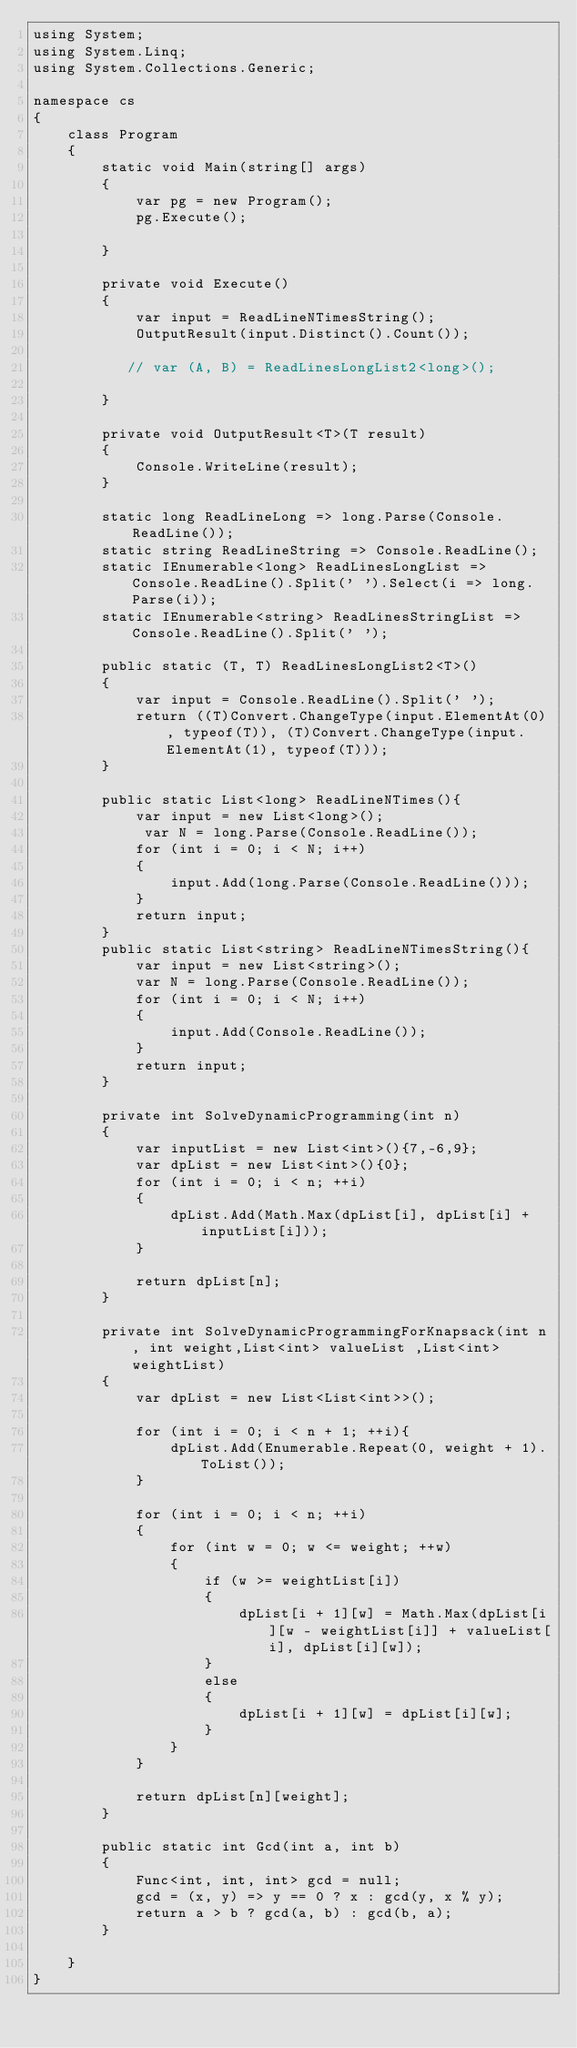<code> <loc_0><loc_0><loc_500><loc_500><_C#_>using System;
using System.Linq;
using System.Collections.Generic;

namespace cs
{
    class Program
    {
        static void Main(string[] args)
        {
            var pg = new Program();
            pg.Execute();

        }

        private void Execute()
        {
            var input = ReadLineNTimesString();
            OutputResult(input.Distinct().Count());

           // var (A, B) = ReadLinesLongList2<long>();

        }

        private void OutputResult<T>(T result)
        {
            Console.WriteLine(result);
        }

        static long ReadLineLong => long.Parse(Console.ReadLine());
        static string ReadLineString => Console.ReadLine();
        static IEnumerable<long> ReadLinesLongList => Console.ReadLine().Split(' ').Select(i => long.Parse(i));
        static IEnumerable<string> ReadLinesStringList => Console.ReadLine().Split(' ');

        public static (T, T) ReadLinesLongList2<T>()
        {
            var input = Console.ReadLine().Split(' ');
            return ((T)Convert.ChangeType(input.ElementAt(0), typeof(T)), (T)Convert.ChangeType(input.ElementAt(1), typeof(T)));
        }

        public static List<long> ReadLineNTimes(){
            var input = new List<long>();
             var N = long.Parse(Console.ReadLine());
            for (int i = 0; i < N; i++)
            {
                input.Add(long.Parse(Console.ReadLine()));
            }
            return input;
        }
        public static List<string> ReadLineNTimesString(){
            var input = new List<string>();
            var N = long.Parse(Console.ReadLine());
            for (int i = 0; i < N; i++)
            {
                input.Add(Console.ReadLine());
            }
            return input;
        }

        private int SolveDynamicProgramming(int n)
        {
            var inputList = new List<int>(){7,-6,9};
            var dpList = new List<int>(){0};
            for (int i = 0; i < n; ++i)
            {
                dpList.Add(Math.Max(dpList[i], dpList[i] + inputList[i]));
            }

            return dpList[n];
        }

        private int SolveDynamicProgrammingForKnapsack(int n, int weight,List<int> valueList ,List<int> weightList)
        {
            var dpList = new List<List<int>>();
            
            for (int i = 0; i < n + 1; ++i){
                dpList.Add(Enumerable.Repeat(0, weight + 1).ToList());
            }

            for (int i = 0; i < n; ++i)
            {
                for (int w = 0; w <= weight; ++w)
                {
                    if (w >= weightList[i])
                    { 
                        dpList[i + 1][w] = Math.Max(dpList[i][w - weightList[i]] + valueList[i], dpList[i][w]);
                    }
                    else 
                    {
                        dpList[i + 1][w] = dpList[i][w];
                    }
                }
            }

            return dpList[n][weight];
        }

        public static int Gcd(int a, int b)
        {
            Func<int, int, int> gcd = null;
            gcd = (x, y) => y == 0 ? x : gcd(y, x % y);
            return a > b ? gcd(a, b) : gcd(b, a);
        }

    }
}
</code> 